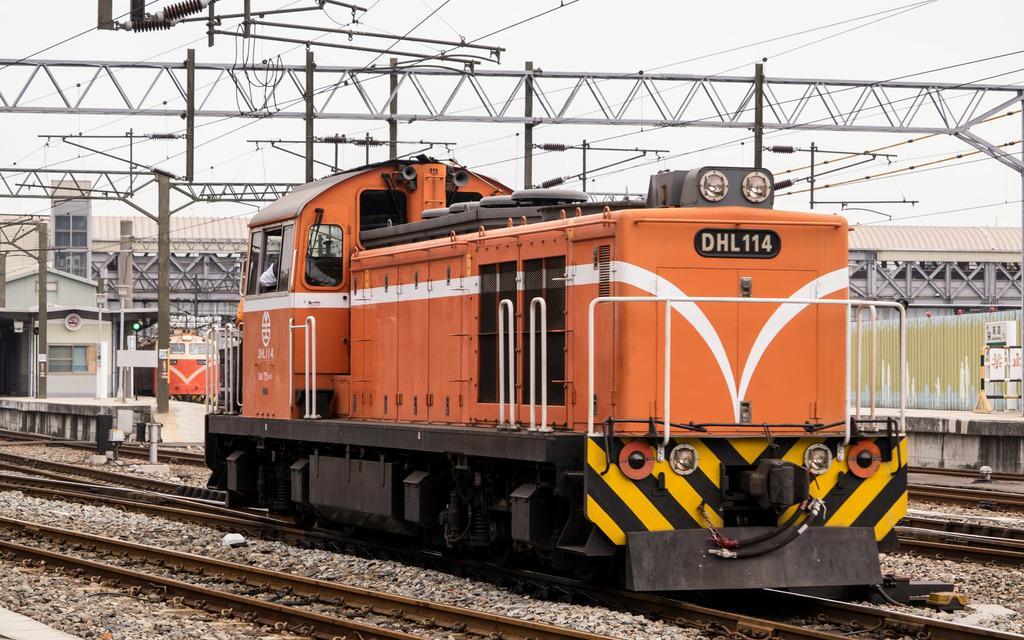Could you give a brief overview of what you see in this image? In the image we can see the train engine on the track. Here we can see the train tracks, electric poles and electric wires. Here we can see the platform, stones and the sky. 